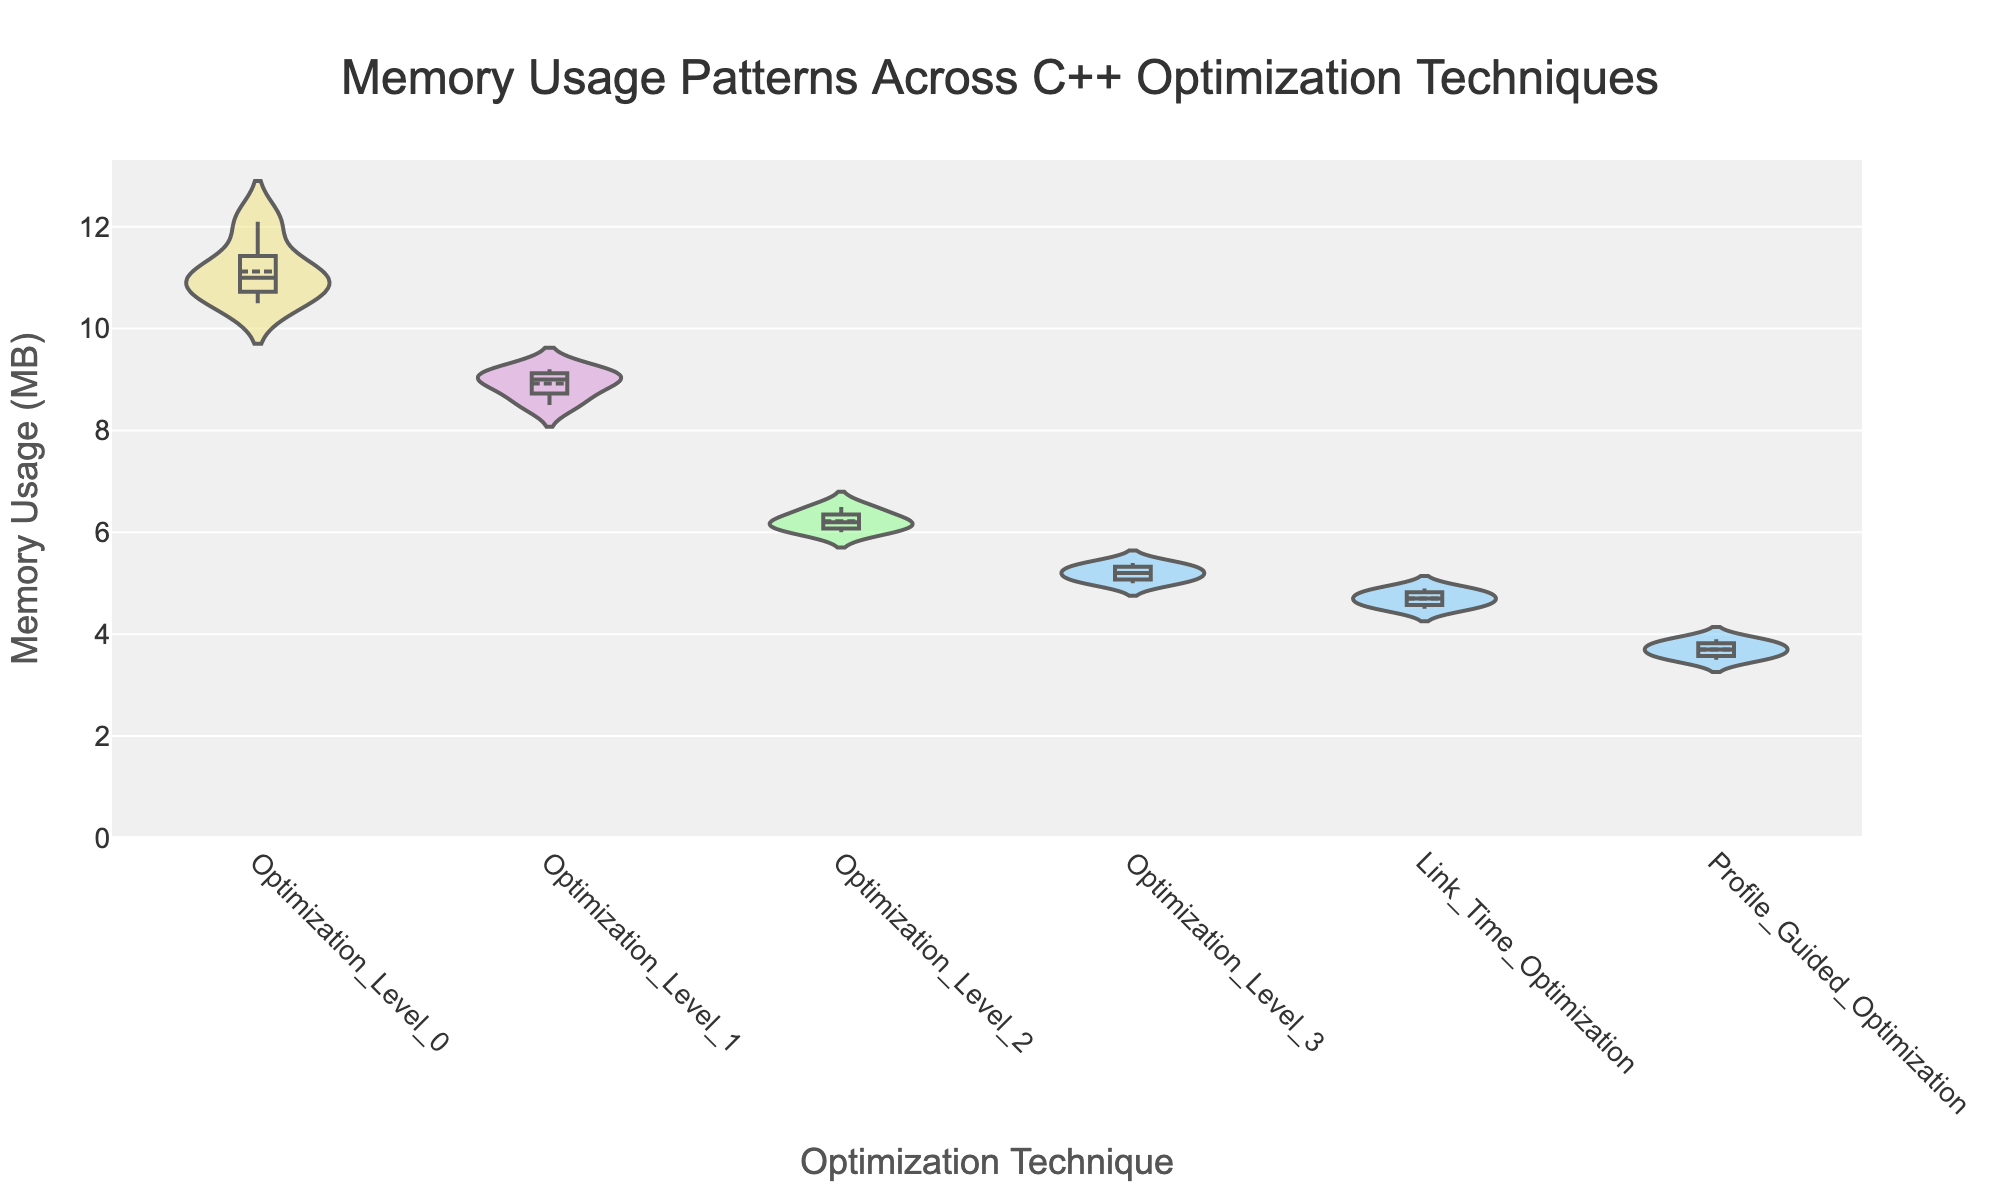What is the title of the figure? The title of the figure is typically located at the top and clearly indicates the main topic of the chart.
Answer: Memory Usage Patterns Across C++ Optimization Techniques Which optimization technique shows the lowest median memory usage? The box in the middle of each violin plot indicates the median value. The technique with the lowest box position has the lowest median memory usage.
Answer: Profile_Guided_Optimization How does the memory usage vary among different optimization levels? The spread of each violin plot shows the distribution of memory usage. The width indicates density, and you can compare the spread among different techniques to see variation.
Answer: Varies significantly, with Profile_Guided_Optimization having the lowest and Optimization_Level_0 having the highest Which technique has the highest maximum memory usage recorded? The maximum value can be observed at the top end of the whiskers in each box plot. The technique with the highest top whisker has the highest maximum memory usage.
Answer: Optimization_Level_0 What is the range of memory usage for Link_Time_Optimization? The range is the difference between the maximum and minimum values. These can be extracted from the top and bottom of the whiskers in the box plot for Link_Time_Optimization.
Answer: 4.8 - 4.5 = 0.3 MB Which optimization technique has the most consistent memory usage? Consistency can be measured by the interquartile range (IQR), which is the range between the first and third quartiles (the middle 50%). The technique with the smallest IQR is the most consistent.
Answer: Profile_Guided_Optimization Between Optimization_Level_2 and Optimization_Level_3, which has a lower median memory usage? Compare the positions of the median lines (the lines inside the boxes) for Optimization_Level_2 and Optimization_Level_3.
Answer: Optimization_Level_3 How does the mean memory usage compare between Optimization_Level_1 and Optimization_Level_2? The mean is indicated by a line inside the violin plot. The technique with the lower mean line has a lower mean memory usage.
Answer: Optimization_Level_2 What kind of color variation is used in the figure to differentiate between techniques? Colors are used to distinguish different techniques. They are unique for each technique for clear differentiation.
Answer: Various colors like light salmon, pale green, sky blue, plum, and khaki Among all techniques, which has the narrowest distribution of memory usage values? The narrowest distribution will be indicated by a violin plot with the smallest spread in the y-axis.
Answer: Profile_Guided_Optimization 